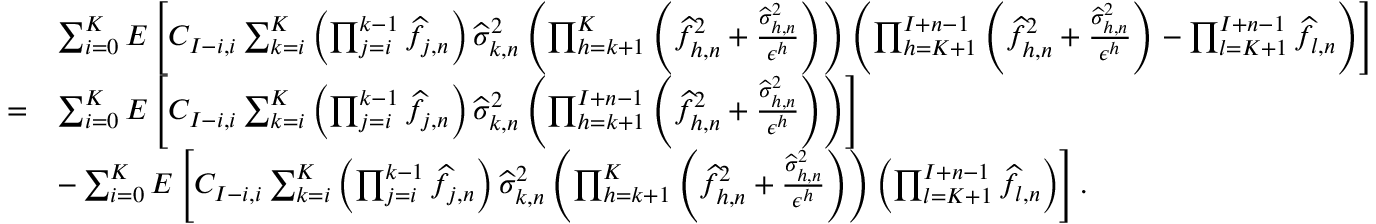Convert formula to latex. <formula><loc_0><loc_0><loc_500><loc_500>\begin{array} { r l } & { \sum _ { i = 0 } ^ { K } E \left [ C _ { I - i , i } \sum _ { k = i } ^ { K } \left ( \prod _ { j = i } ^ { k - 1 } \widehat { f } _ { j , n } \right ) \widehat { \sigma } _ { k , n } ^ { 2 } \left ( \prod _ { h = k + 1 } ^ { K } \left ( \widehat { f } _ { h , n } ^ { 2 } + \frac { \widehat { \sigma } _ { h , n } ^ { 2 } } { \epsilon ^ { h } } \right ) \right ) \left ( \prod _ { h = K + 1 } ^ { I + n - 1 } \left ( \widehat { f } _ { h , n } ^ { 2 } + \frac { \widehat { \sigma } _ { h , n } ^ { 2 } } { \epsilon ^ { h } } \right ) - \prod _ { l = K + 1 } ^ { I + n - 1 } \widehat { f } _ { l , n } \right ) \right ] } \\ { = } & { \sum _ { i = 0 } ^ { K } E \left [ C _ { I - i , i } \sum _ { k = i } ^ { K } \left ( \prod _ { j = i } ^ { k - 1 } \widehat { f } _ { j , n } \right ) \widehat { \sigma } _ { k , n } ^ { 2 } \left ( \prod _ { h = k + 1 } ^ { I + n - 1 } \left ( \widehat { f } _ { h , n } ^ { 2 } + \frac { \widehat { \sigma } _ { h , n } ^ { 2 } } { \epsilon ^ { h } } \right ) \right ) \right ] } \\ & { - \sum _ { i = 0 } ^ { K } E \left [ C _ { I - i , i } \sum _ { k = i } ^ { K } \left ( \prod _ { j = i } ^ { k - 1 } \widehat { f } _ { j , n } \right ) \widehat { \sigma } _ { k , n } ^ { 2 } \left ( \prod _ { h = k + 1 } ^ { K } \left ( \widehat { f } _ { h , n } ^ { 2 } + \frac { \widehat { \sigma } _ { h , n } ^ { 2 } } { \epsilon ^ { h } } \right ) \right ) \left ( \prod _ { l = K + 1 } ^ { I + n - 1 } \widehat { f } _ { l , n } \right ) \right ] . } \end{array}</formula> 